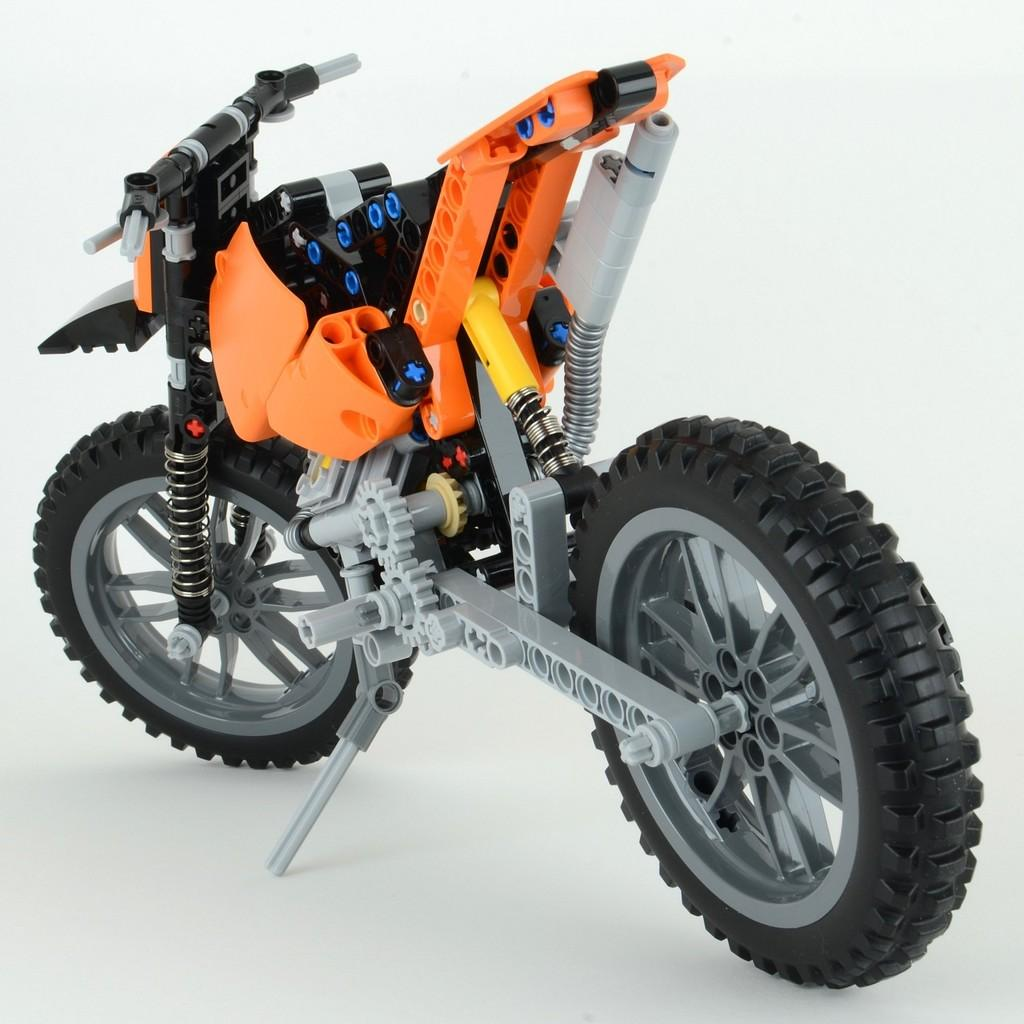What type of motor vehicle is in the image? The specific type of motor vehicle cannot be determined from the provided fact. What color are the trousers worn by the letter in the image? There is no letter or trousers present in the image. 